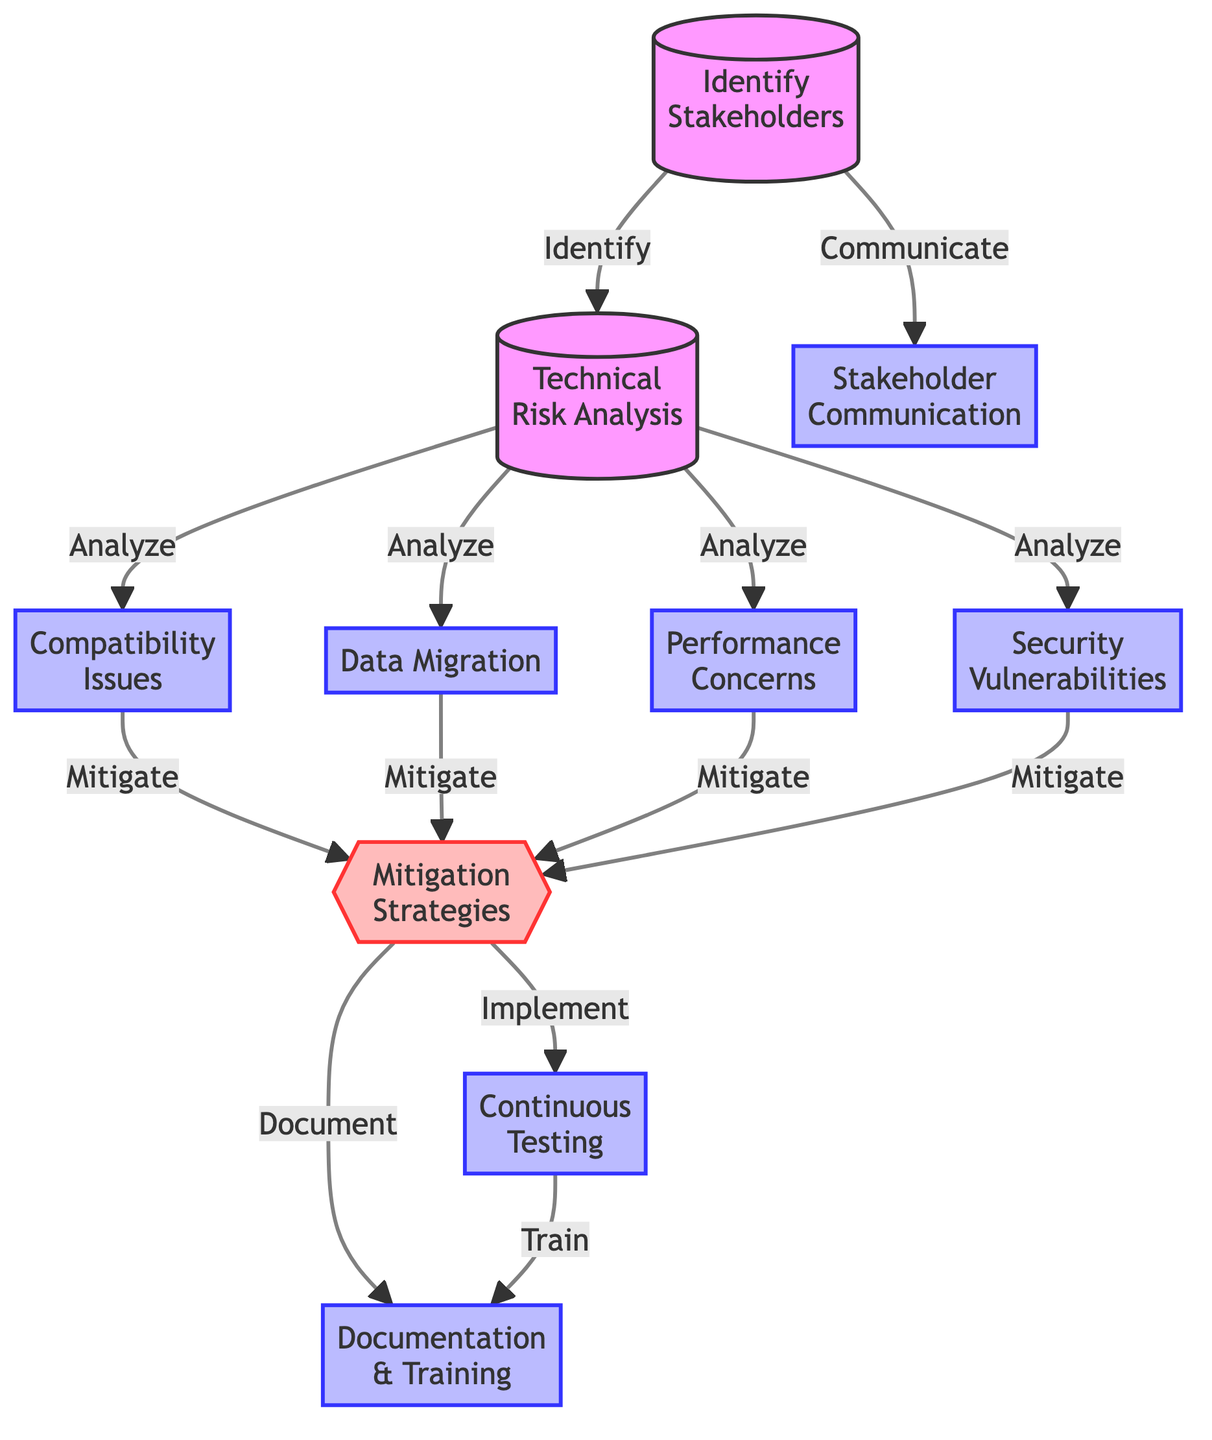What is the first node in the diagram? The first node listed in the diagram is "Identify Stakeholders." This is confirmed by its position at the top of the flowchart, clearly marked as the starting point for the flow of the diagram.
Answer: Identify Stakeholders How many main risk categories are analyzed in the diagram? The diagram shows four main risk categories being analyzed: Compatibility Issues, Data Migration, Performance Concerns, and Security Vulnerabilities. These are listed as the nodes branching out from the node "Technical Risk Analysis."
Answer: Four What does the "Mitigation Strategies" node lead to? The "Mitigation Strategies" node leads to two nodes: "Continuous Testing" and "Documentation & Training." This is indicated by the arrows pointing from the "Mitigation Strategies" node to these two subsequent nodes in the diagram.
Answer: Continuous Testing, Documentation & Training Which node is directly connected to the "Identify Stakeholders" node? The "Identify Stakeholders" node is directly connected to the "Stakeholder Communication" node, as indicated by the arrow that flows from "Identify Stakeholders" to "Stakeholder Communication."
Answer: Stakeholder Communication What is the purpose of the "Technical Risk Analysis" node? The "Technical Risk Analysis" node serves as an analytical step that leads to the examination of four specific technical risks: Compatibility Issues, Data Migration, Performance Concerns, and Security Vulnerabilities. Each is analyzed to identify potential risks during the migration.
Answer: Analyze Risks Which two nodes are focused on stakeholder involvement? The two nodes focused on stakeholder involvement are "Identify Stakeholders" and "Stakeholder Communication." The first involves recognizing who the stakeholders are, and the second emphasizes the importance of communicating with them throughout the migration process.
Answer: Identify Stakeholders, Stakeholder Communication 